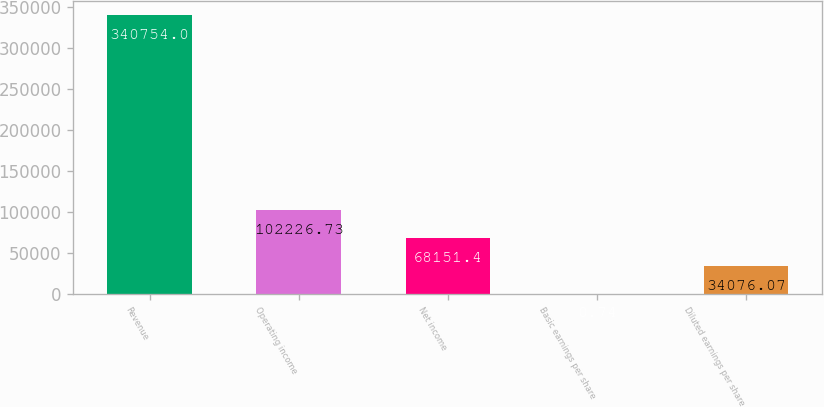Convert chart. <chart><loc_0><loc_0><loc_500><loc_500><bar_chart><fcel>Revenue<fcel>Operating income<fcel>Net income<fcel>Basic earnings per share<fcel>Diluted earnings per share<nl><fcel>340754<fcel>102227<fcel>68151.4<fcel>0.74<fcel>34076.1<nl></chart> 